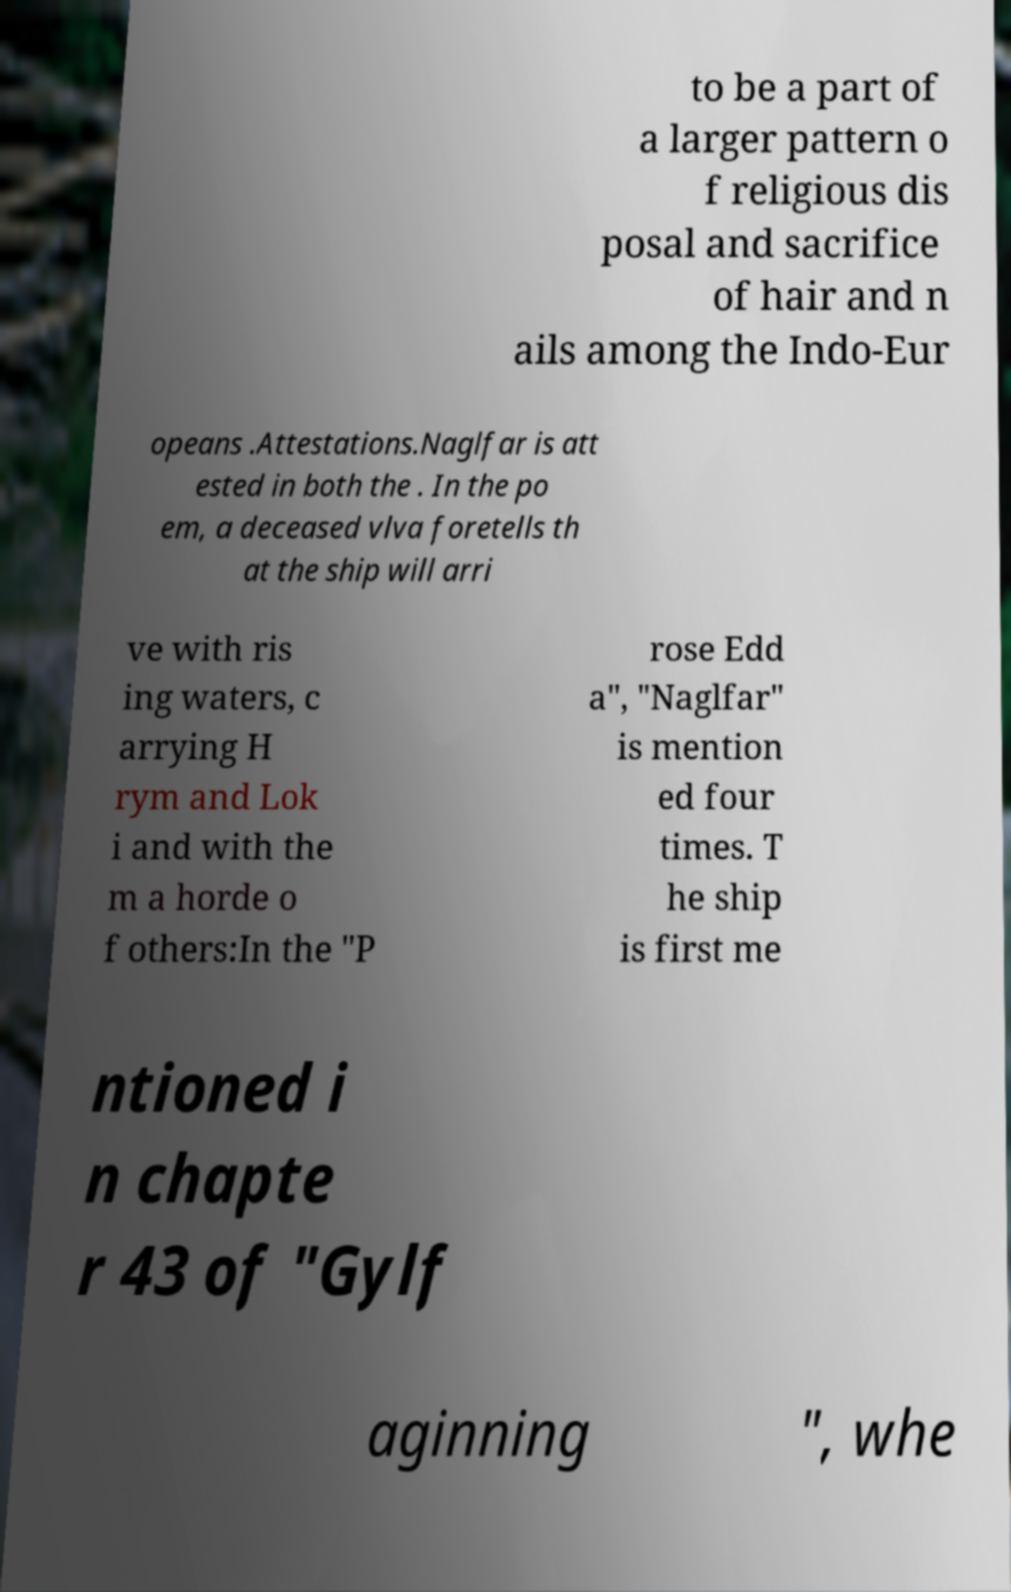I need the written content from this picture converted into text. Can you do that? to be a part of a larger pattern o f religious dis posal and sacrifice of hair and n ails among the Indo-Eur opeans .Attestations.Naglfar is att ested in both the . In the po em, a deceased vlva foretells th at the ship will arri ve with ris ing waters, c arrying H rym and Lok i and with the m a horde o f others:In the "P rose Edd a", "Naglfar" is mention ed four times. T he ship is first me ntioned i n chapte r 43 of "Gylf aginning ", whe 